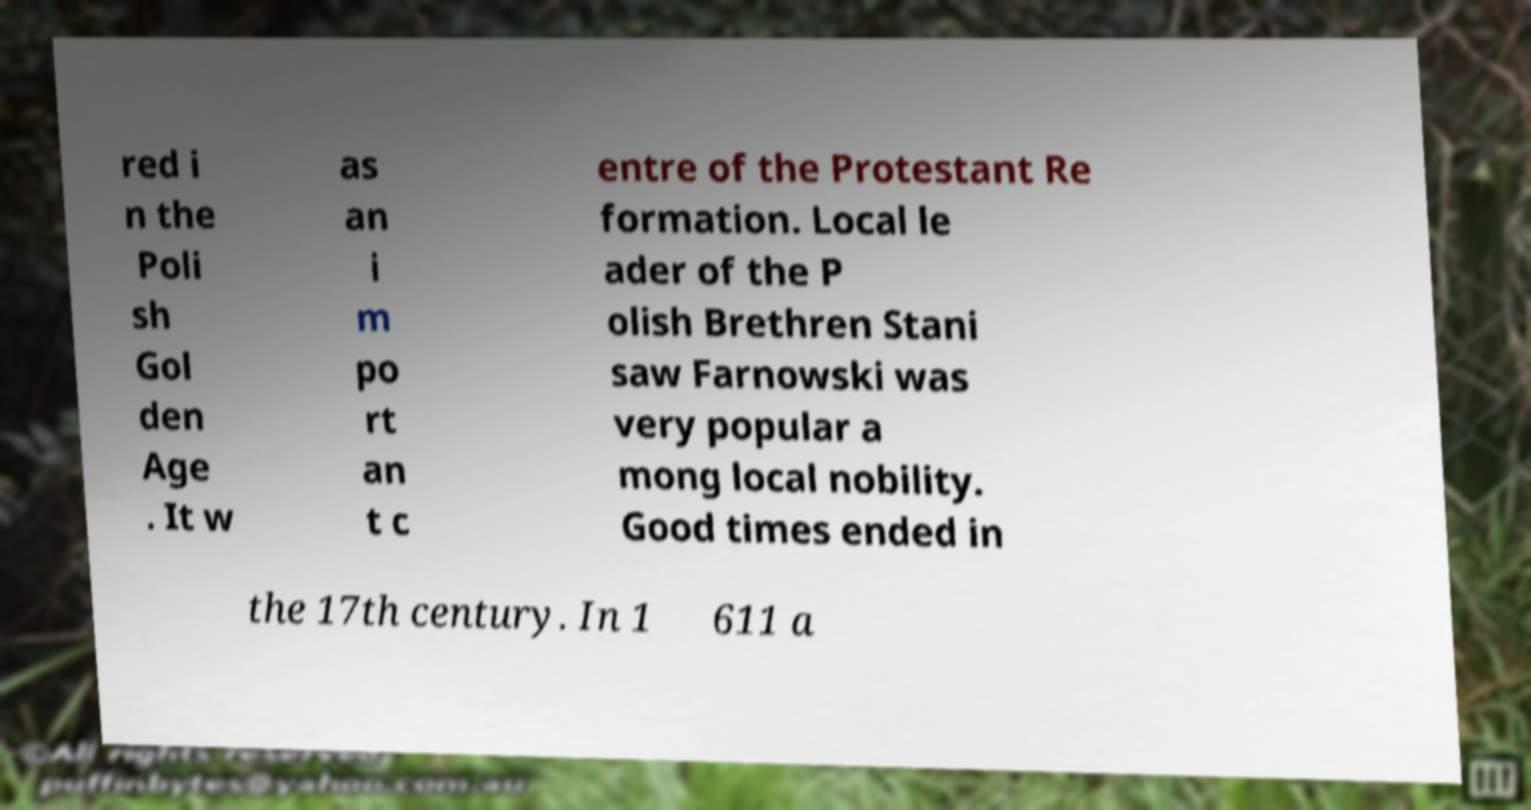There's text embedded in this image that I need extracted. Can you transcribe it verbatim? red i n the Poli sh Gol den Age . It w as an i m po rt an t c entre of the Protestant Re formation. Local le ader of the P olish Brethren Stani saw Farnowski was very popular a mong local nobility. Good times ended in the 17th century. In 1 611 a 